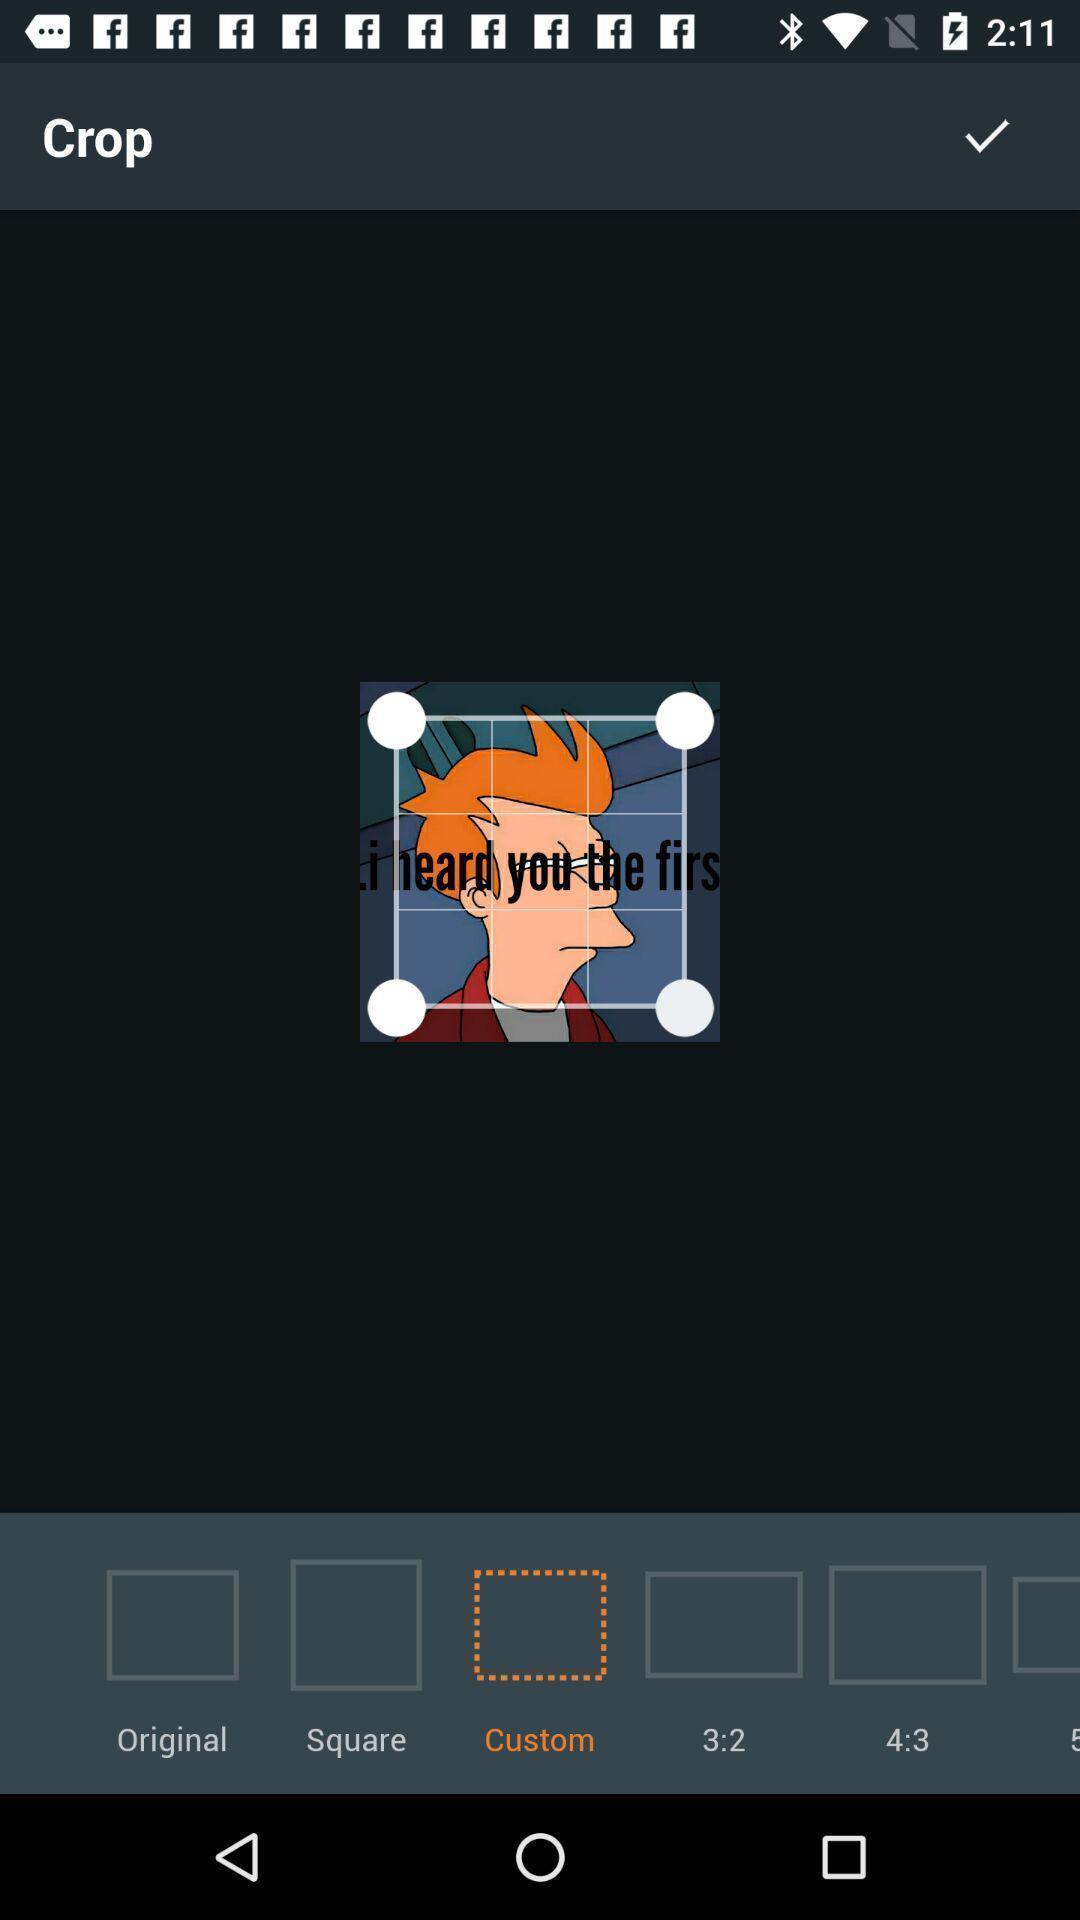Provide a description of this screenshot. Page showing the options for cropping app. 